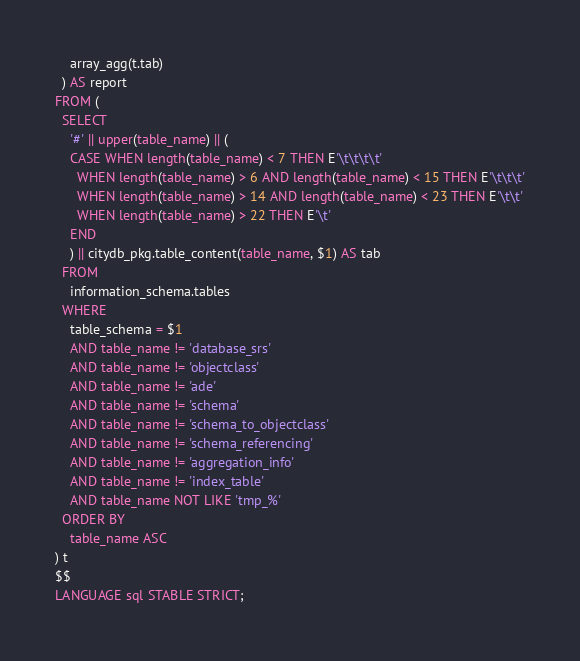<code> <loc_0><loc_0><loc_500><loc_500><_SQL_>    array_agg(t.tab)
  ) AS report
FROM (
  SELECT
    '#' || upper(table_name) || (
    CASE WHEN length(table_name) < 7 THEN E'\t\t\t\t'
      WHEN length(table_name) > 6 AND length(table_name) < 15 THEN E'\t\t\t'
      WHEN length(table_name) > 14 AND length(table_name) < 23 THEN E'\t\t'
      WHEN length(table_name) > 22 THEN E'\t'
    END
    ) || citydb_pkg.table_content(table_name, $1) AS tab 
  FROM
    information_schema.tables
  WHERE 
    table_schema = $1
    AND table_name != 'database_srs' 
    AND table_name != 'objectclass'
    AND table_name != 'ade'
    AND table_name != 'schema'
    AND table_name != 'schema_to_objectclass' 
    AND table_name != 'schema_referencing'
    AND table_name != 'aggregation_info'
    AND table_name != 'index_table'
    AND table_name NOT LIKE 'tmp_%'
  ORDER BY
    table_name ASC
) t
$$
LANGUAGE sql STABLE STRICT;</code> 